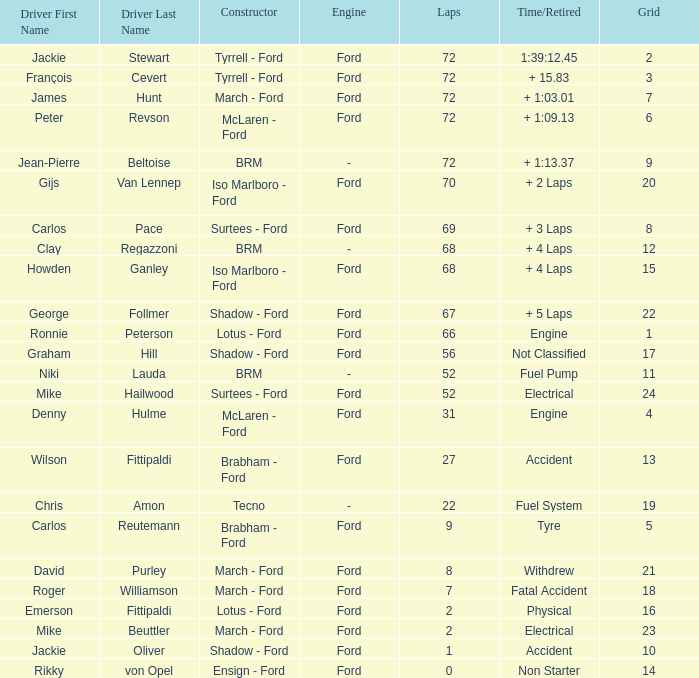Can you parse all the data within this table? {'header': ['Driver First Name', 'Driver Last Name', 'Constructor', 'Engine', 'Laps', 'Time/Retired', 'Grid'], 'rows': [['Jackie', 'Stewart', 'Tyrrell - Ford', 'Ford', '72', '1:39:12.45', '2'], ['François', 'Cevert', 'Tyrrell - Ford', 'Ford', '72', '+ 15.83', '3'], ['James', 'Hunt', 'March - Ford', 'Ford', '72', '+ 1:03.01', '7'], ['Peter', 'Revson', 'McLaren - Ford', 'Ford', '72', '+ 1:09.13', '6'], ['Jean-Pierre', 'Beltoise', 'BRM', '-', '72', '+ 1:13.37', '9'], ['Gijs', 'Van Lennep', 'Iso Marlboro - Ford', 'Ford', '70', '+ 2 Laps', '20'], ['Carlos', 'Pace', 'Surtees - Ford', 'Ford', '69', '+ 3 Laps', '8'], ['Clay', 'Regazzoni', 'BRM', '-', '68', '+ 4 Laps', '12'], ['Howden', 'Ganley', 'Iso Marlboro - Ford', 'Ford', '68', '+ 4 Laps', '15'], ['George', 'Follmer', 'Shadow - Ford', 'Ford', '67', '+ 5 Laps', '22'], ['Ronnie', 'Peterson', 'Lotus - Ford', 'Ford', '66', 'Engine', '1'], ['Graham', 'Hill', 'Shadow - Ford', 'Ford', '56', 'Not Classified', '17'], ['Niki', 'Lauda', 'BRM', '-', '52', 'Fuel Pump', '11'], ['Mike', 'Hailwood', 'Surtees - Ford', 'Ford', '52', 'Electrical', '24'], ['Denny', 'Hulme', 'McLaren - Ford', 'Ford', '31', 'Engine', '4'], ['Wilson', 'Fittipaldi', 'Brabham - Ford', 'Ford', '27', 'Accident', '13'], ['Chris', 'Amon', 'Tecno', '-', '22', 'Fuel System', '19'], ['Carlos', 'Reutemann', 'Brabham - Ford', 'Ford', '9', 'Tyre', '5'], ['David', 'Purley', 'March - Ford', 'Ford', '8', 'Withdrew', '21'], ['Roger', 'Williamson', 'March - Ford', 'Ford', '7', 'Fatal Accident', '18'], ['Emerson', 'Fittipaldi', 'Lotus - Ford', 'Ford', '2', 'Physical', '16'], ['Mike', 'Beuttler', 'March - Ford', 'Ford', '2', 'Electrical', '23'], ['Jackie', 'Oliver', 'Shadow - Ford', 'Ford', '1', 'Accident', '10'], ['Rikky', 'von Opel', 'Ensign - Ford', 'Ford', '0', 'Non Starter', '14']]} What is the top grid that laps less than 66 and a retried engine? 4.0. 